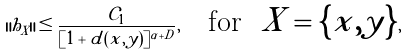<formula> <loc_0><loc_0><loc_500><loc_500>\| h _ { X } \| \leq \frac { \mathcal { C } _ { 1 } } { [ 1 + d ( x , y ) ] ^ { \alpha + D } } , \quad \text {for \ $X=\{x,y\}$} ,</formula> 